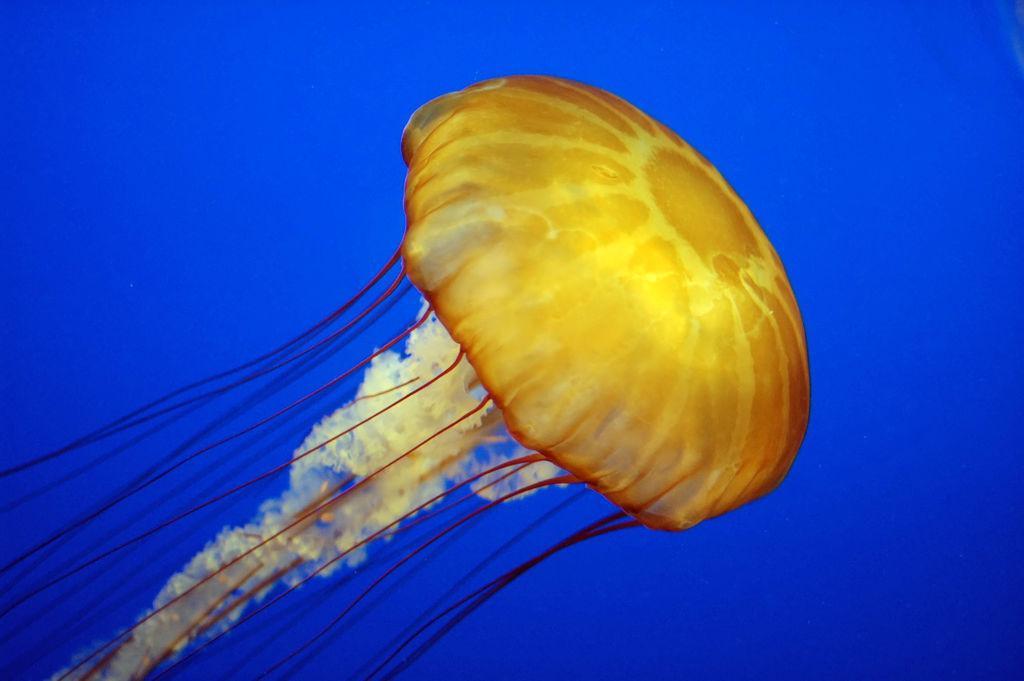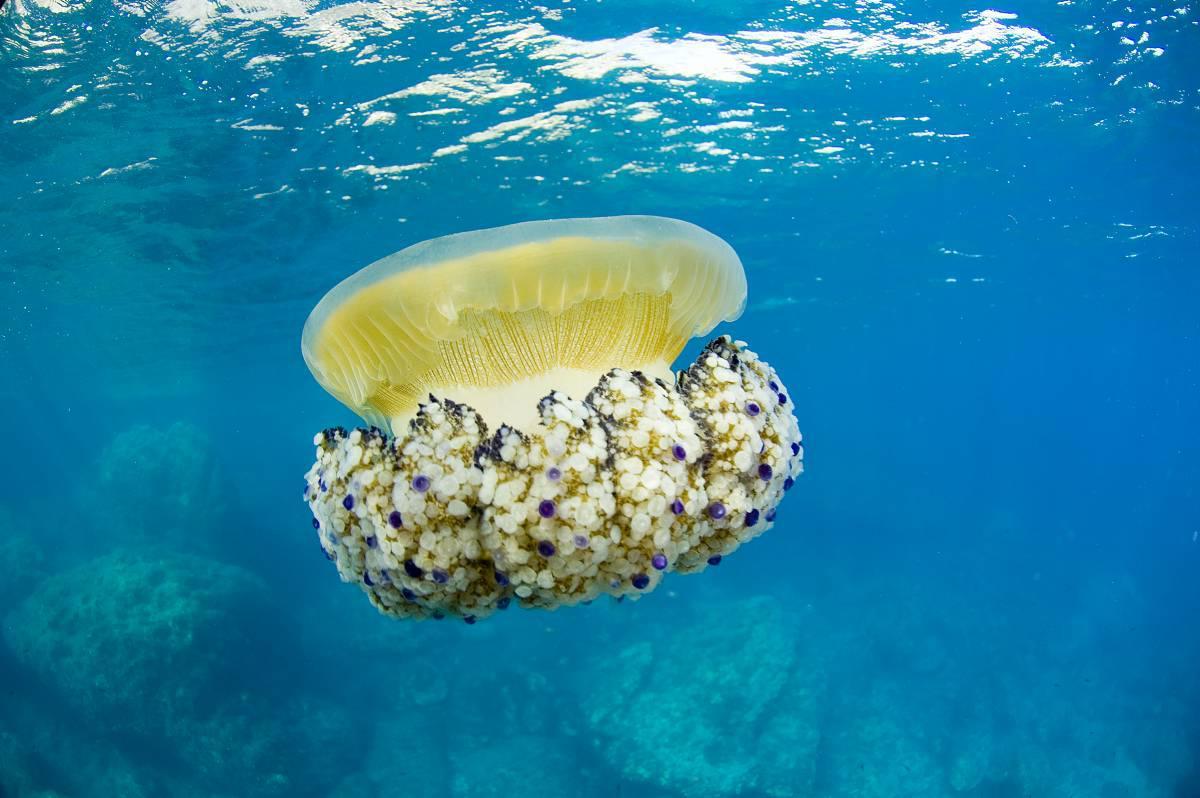The first image is the image on the left, the second image is the image on the right. Analyze the images presented: Is the assertion "in the left image a jellyfish is swimming toward the left" valid? Answer yes or no. No. The first image is the image on the left, the second image is the image on the right. Assess this claim about the two images: "At least one of the jellyfish clearly has white spots all over the bell.". Correct or not? Answer yes or no. No. 